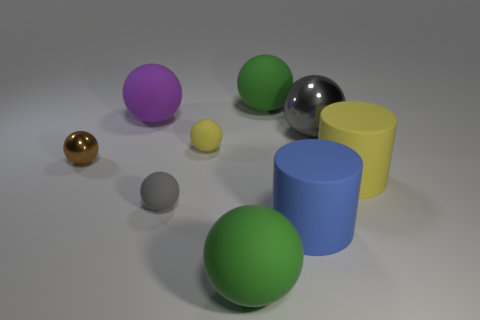Subtract all green matte balls. How many balls are left? 5 Add 1 cyan metal objects. How many objects exist? 10 Subtract all gray balls. How many balls are left? 5 Subtract all cylinders. How many objects are left? 7 Subtract 7 spheres. How many spheres are left? 0 Subtract all blue balls. How many blue cylinders are left? 1 Add 6 large purple objects. How many large purple objects are left? 7 Add 4 large red objects. How many large red objects exist? 4 Subtract 1 gray balls. How many objects are left? 8 Subtract all cyan spheres. Subtract all red cubes. How many spheres are left? 7 